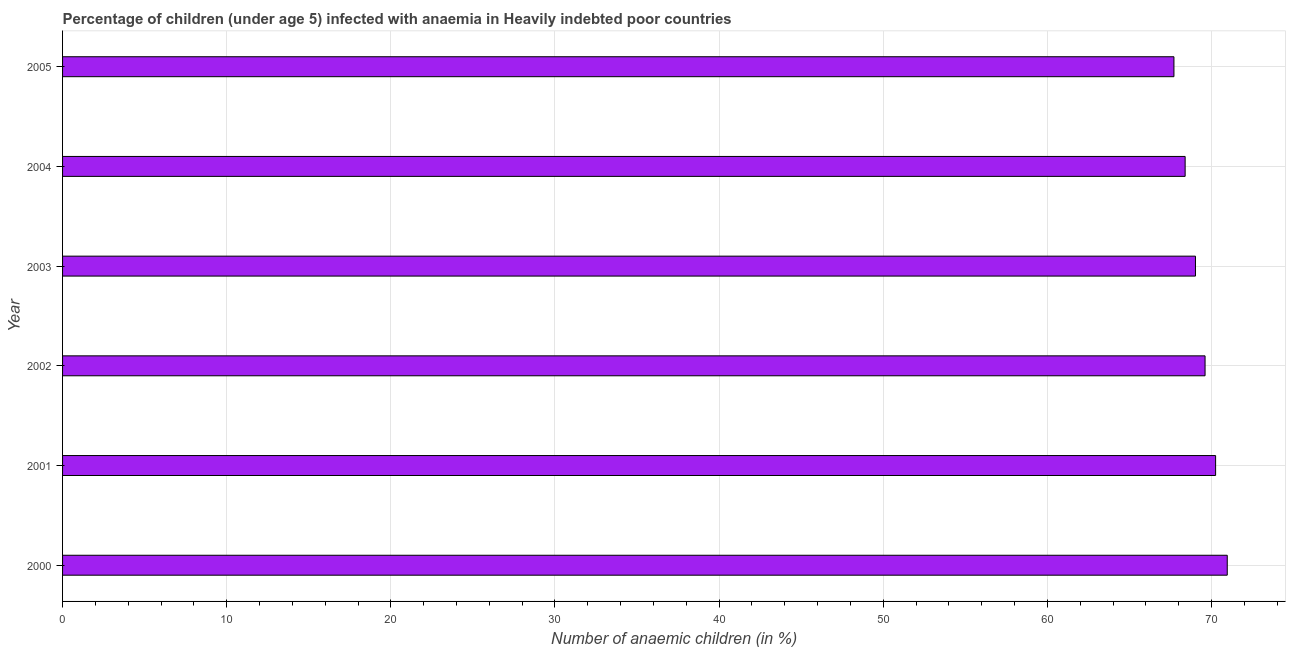Does the graph contain any zero values?
Provide a succinct answer. No. Does the graph contain grids?
Provide a succinct answer. Yes. What is the title of the graph?
Your answer should be very brief. Percentage of children (under age 5) infected with anaemia in Heavily indebted poor countries. What is the label or title of the X-axis?
Provide a succinct answer. Number of anaemic children (in %). What is the label or title of the Y-axis?
Give a very brief answer. Year. What is the number of anaemic children in 2003?
Your response must be concise. 69.02. Across all years, what is the maximum number of anaemic children?
Your response must be concise. 70.96. Across all years, what is the minimum number of anaemic children?
Offer a terse response. 67.71. What is the sum of the number of anaemic children?
Provide a succinct answer. 415.95. What is the difference between the number of anaemic children in 2003 and 2005?
Ensure brevity in your answer.  1.31. What is the average number of anaemic children per year?
Provide a succinct answer. 69.33. What is the median number of anaemic children?
Keep it short and to the point. 69.32. What is the ratio of the number of anaemic children in 2003 to that in 2005?
Ensure brevity in your answer.  1.02. What is the difference between the highest and the second highest number of anaemic children?
Provide a succinct answer. 0.71. Is the sum of the number of anaemic children in 2001 and 2002 greater than the maximum number of anaemic children across all years?
Ensure brevity in your answer.  Yes. What is the difference between the highest and the lowest number of anaemic children?
Offer a very short reply. 3.25. In how many years, is the number of anaemic children greater than the average number of anaemic children taken over all years?
Make the answer very short. 3. How many years are there in the graph?
Give a very brief answer. 6. What is the difference between two consecutive major ticks on the X-axis?
Make the answer very short. 10. Are the values on the major ticks of X-axis written in scientific E-notation?
Make the answer very short. No. What is the Number of anaemic children (in %) of 2000?
Offer a terse response. 70.96. What is the Number of anaemic children (in %) in 2001?
Your response must be concise. 70.25. What is the Number of anaemic children (in %) of 2002?
Make the answer very short. 69.61. What is the Number of anaemic children (in %) in 2003?
Offer a very short reply. 69.02. What is the Number of anaemic children (in %) of 2004?
Your answer should be compact. 68.39. What is the Number of anaemic children (in %) of 2005?
Keep it short and to the point. 67.71. What is the difference between the Number of anaemic children (in %) in 2000 and 2001?
Your answer should be compact. 0.71. What is the difference between the Number of anaemic children (in %) in 2000 and 2002?
Your answer should be very brief. 1.35. What is the difference between the Number of anaemic children (in %) in 2000 and 2003?
Make the answer very short. 1.94. What is the difference between the Number of anaemic children (in %) in 2000 and 2004?
Give a very brief answer. 2.57. What is the difference between the Number of anaemic children (in %) in 2000 and 2005?
Provide a succinct answer. 3.25. What is the difference between the Number of anaemic children (in %) in 2001 and 2002?
Provide a succinct answer. 0.64. What is the difference between the Number of anaemic children (in %) in 2001 and 2003?
Your response must be concise. 1.23. What is the difference between the Number of anaemic children (in %) in 2001 and 2004?
Make the answer very short. 1.86. What is the difference between the Number of anaemic children (in %) in 2001 and 2005?
Keep it short and to the point. 2.54. What is the difference between the Number of anaemic children (in %) in 2002 and 2003?
Your answer should be compact. 0.58. What is the difference between the Number of anaemic children (in %) in 2002 and 2004?
Your response must be concise. 1.21. What is the difference between the Number of anaemic children (in %) in 2002 and 2005?
Provide a short and direct response. 1.9. What is the difference between the Number of anaemic children (in %) in 2003 and 2004?
Ensure brevity in your answer.  0.63. What is the difference between the Number of anaemic children (in %) in 2003 and 2005?
Provide a succinct answer. 1.31. What is the difference between the Number of anaemic children (in %) in 2004 and 2005?
Offer a terse response. 0.68. What is the ratio of the Number of anaemic children (in %) in 2000 to that in 2003?
Keep it short and to the point. 1.03. What is the ratio of the Number of anaemic children (in %) in 2000 to that in 2004?
Ensure brevity in your answer.  1.04. What is the ratio of the Number of anaemic children (in %) in 2000 to that in 2005?
Provide a short and direct response. 1.05. What is the ratio of the Number of anaemic children (in %) in 2001 to that in 2003?
Keep it short and to the point. 1.02. What is the ratio of the Number of anaemic children (in %) in 2001 to that in 2004?
Keep it short and to the point. 1.03. What is the ratio of the Number of anaemic children (in %) in 2001 to that in 2005?
Give a very brief answer. 1.04. What is the ratio of the Number of anaemic children (in %) in 2002 to that in 2003?
Your answer should be very brief. 1.01. What is the ratio of the Number of anaemic children (in %) in 2002 to that in 2004?
Make the answer very short. 1.02. What is the ratio of the Number of anaemic children (in %) in 2002 to that in 2005?
Your answer should be compact. 1.03. 